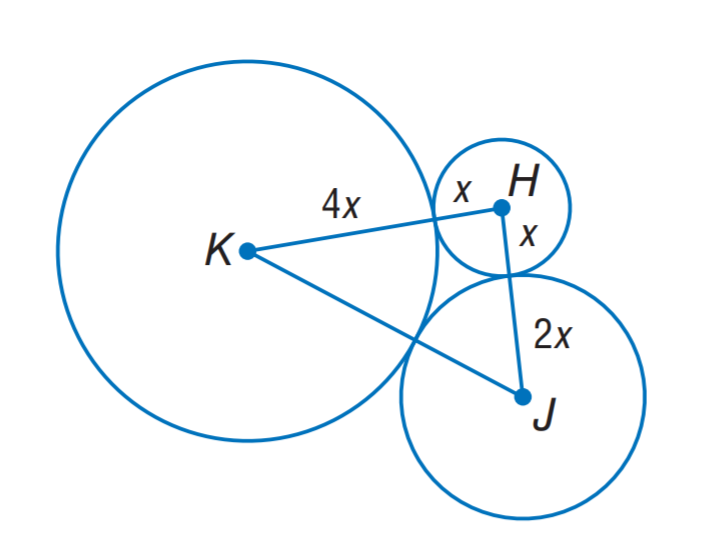Question: The sum of the circumference of circles H, J, K is 56 \pi units. Find K J.
Choices:
A. 12
B. 24
C. 28
D. 56
Answer with the letter. Answer: B 